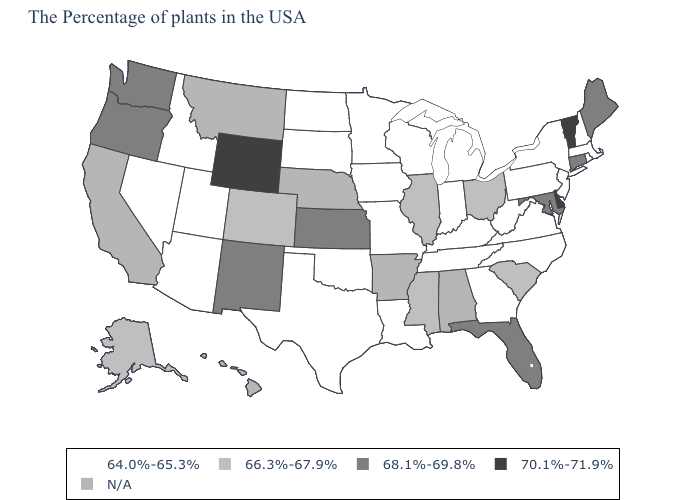Among the states that border Arizona , which have the lowest value?
Short answer required. Utah, Nevada. Does the map have missing data?
Concise answer only. Yes. What is the value of Michigan?
Concise answer only. 64.0%-65.3%. What is the value of Ohio?
Short answer required. 66.3%-67.9%. Does Florida have the highest value in the USA?
Keep it brief. No. What is the value of Illinois?
Concise answer only. 66.3%-67.9%. Is the legend a continuous bar?
Give a very brief answer. No. Does the first symbol in the legend represent the smallest category?
Concise answer only. Yes. Name the states that have a value in the range N/A?
Concise answer only. Alabama, Arkansas, Nebraska, Montana, California, Hawaii. Name the states that have a value in the range 64.0%-65.3%?
Concise answer only. Massachusetts, Rhode Island, New Hampshire, New York, New Jersey, Pennsylvania, Virginia, North Carolina, West Virginia, Georgia, Michigan, Kentucky, Indiana, Tennessee, Wisconsin, Louisiana, Missouri, Minnesota, Iowa, Oklahoma, Texas, South Dakota, North Dakota, Utah, Arizona, Idaho, Nevada. What is the value of Missouri?
Quick response, please. 64.0%-65.3%. What is the value of Texas?
Concise answer only. 64.0%-65.3%. 